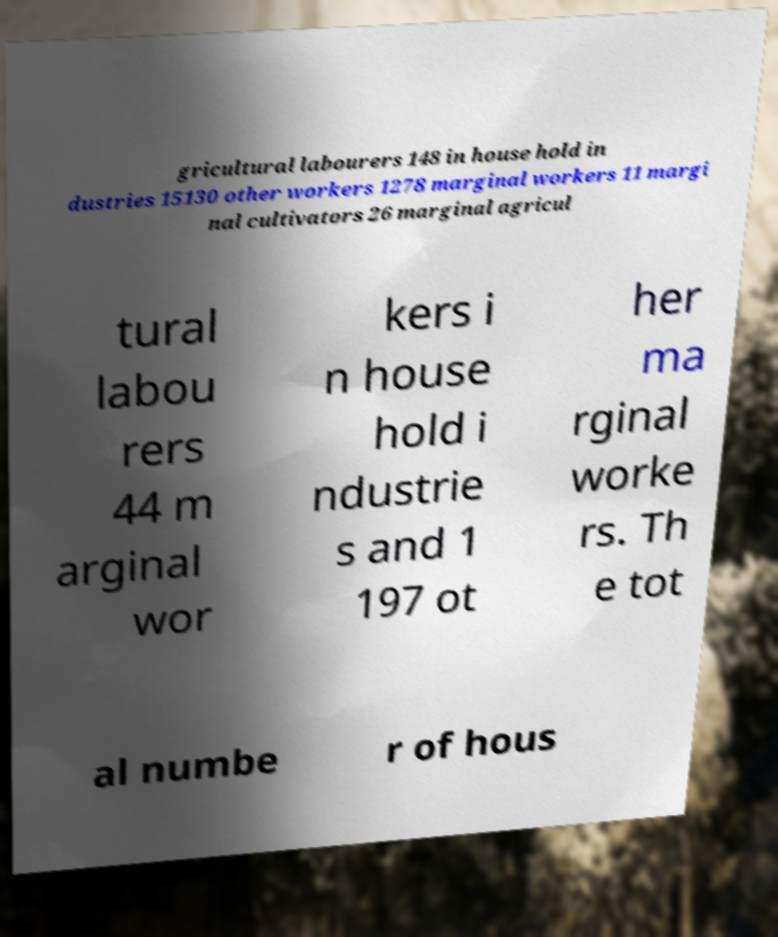Can you read and provide the text displayed in the image?This photo seems to have some interesting text. Can you extract and type it out for me? gricultural labourers 148 in house hold in dustries 15130 other workers 1278 marginal workers 11 margi nal cultivators 26 marginal agricul tural labou rers 44 m arginal wor kers i n house hold i ndustrie s and 1 197 ot her ma rginal worke rs. Th e tot al numbe r of hous 